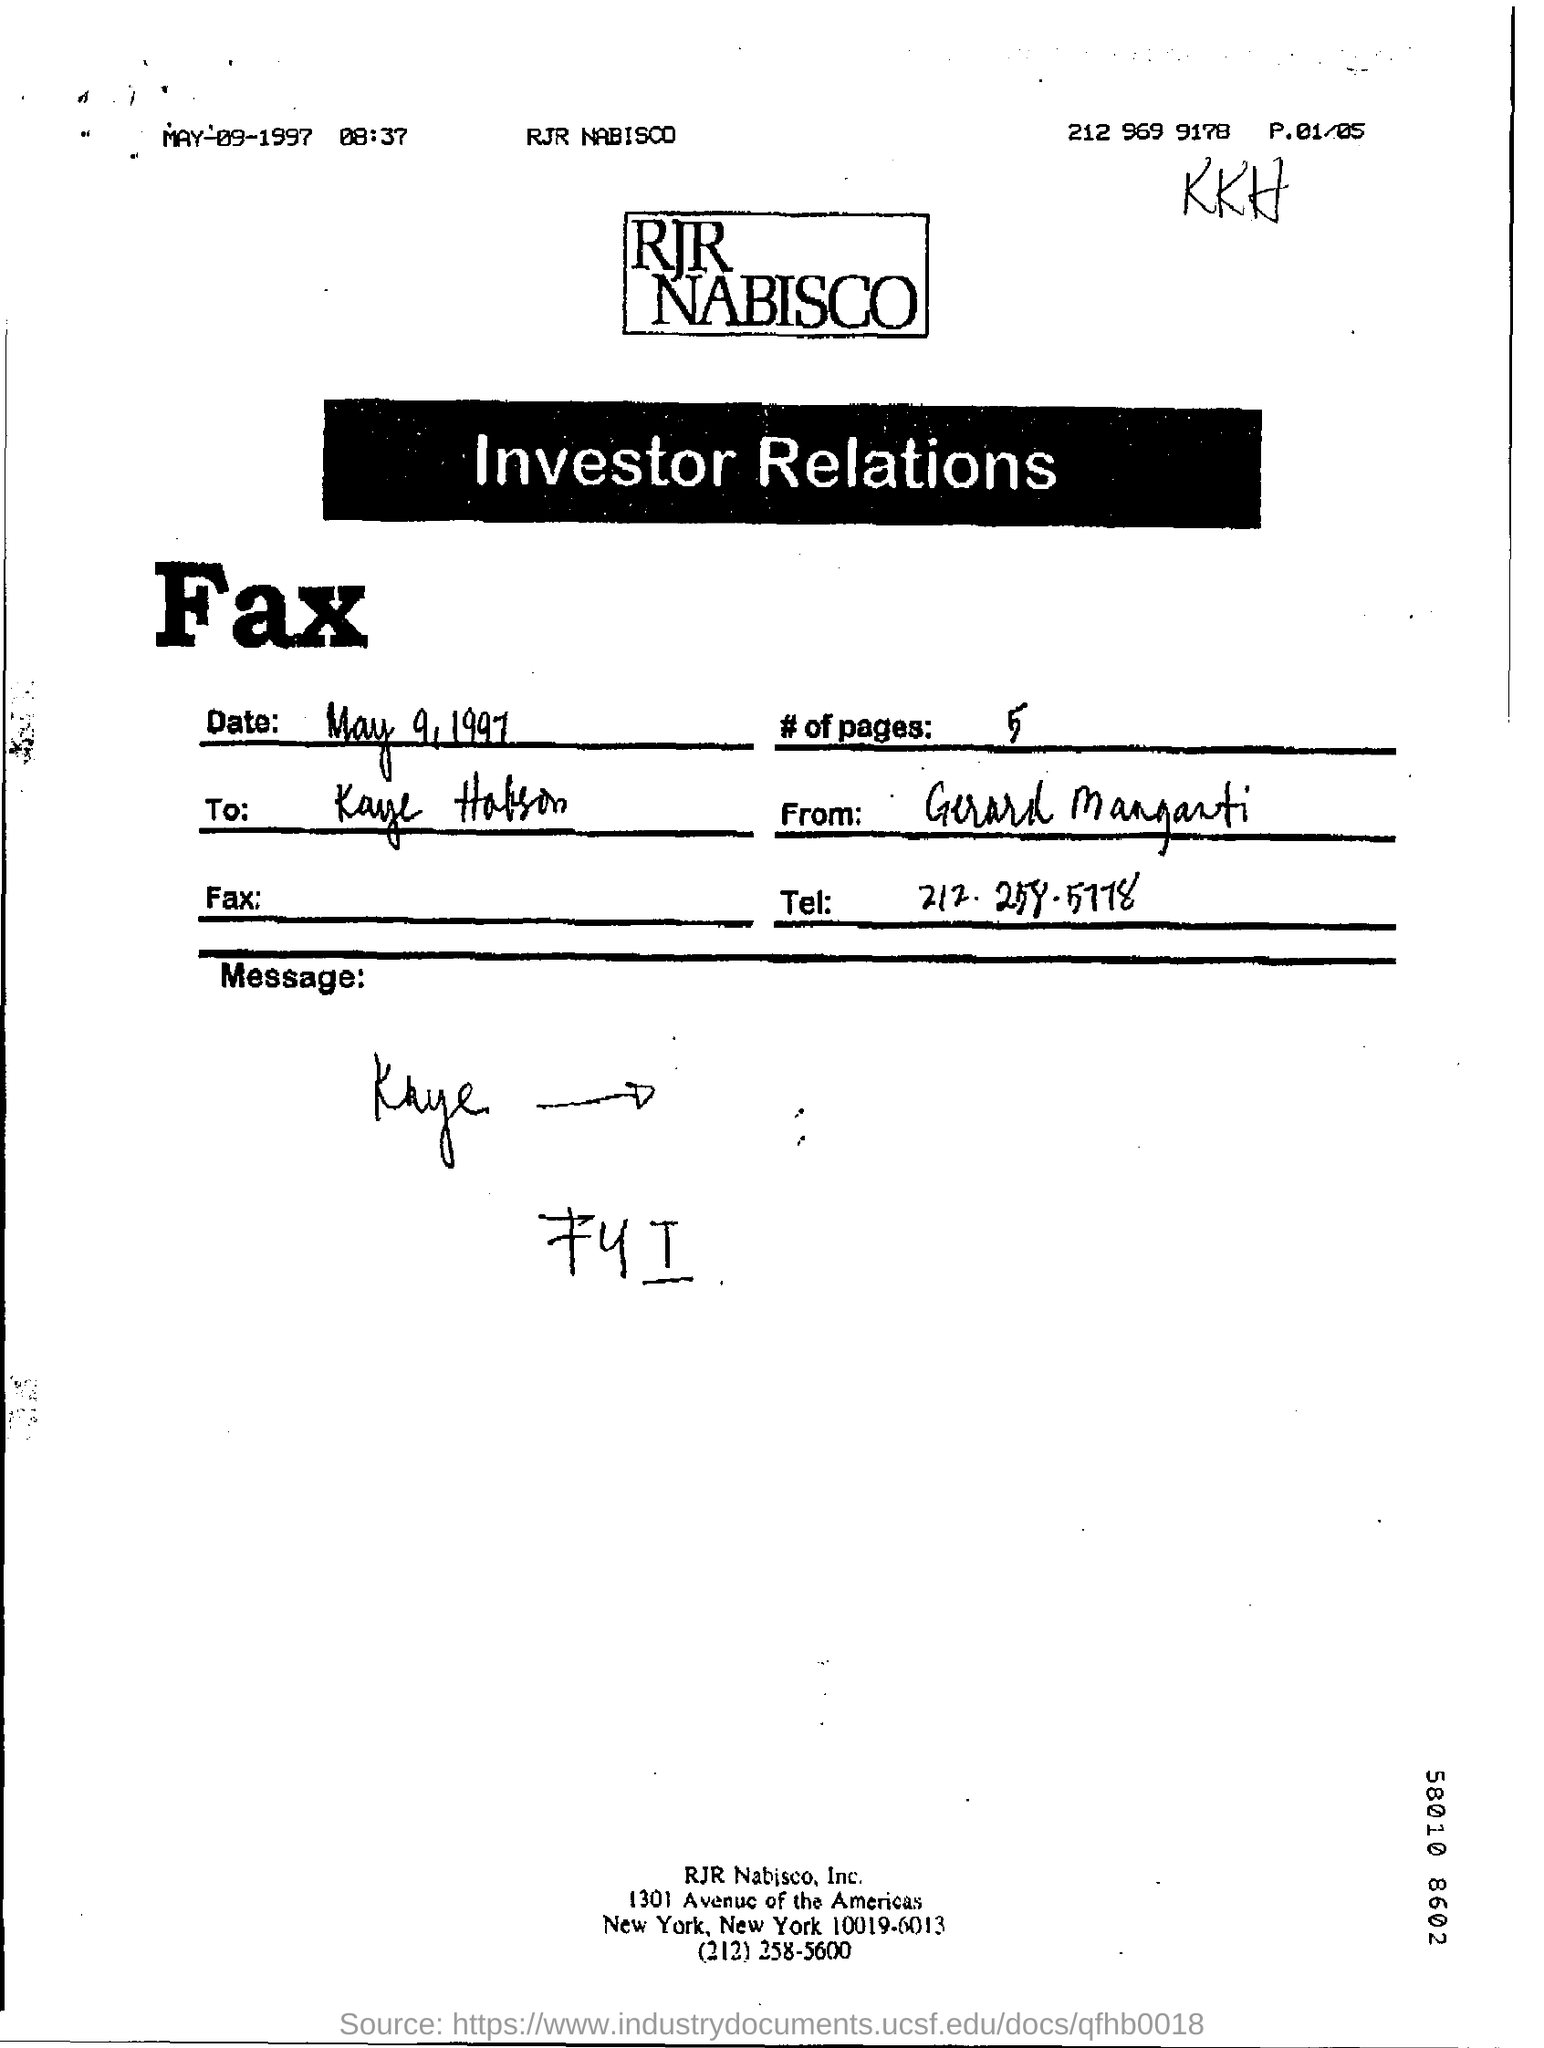Outline some significant characteristics in this image. The fax transmission occurred on May 9th, 1997. The number of pages in the fax is five. The telephone number mentioned in the fax is 212-258-5778. 